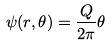Convert formula to latex. <formula><loc_0><loc_0><loc_500><loc_500>\psi ( r , \theta ) = \frac { Q } { 2 \pi } \theta</formula> 